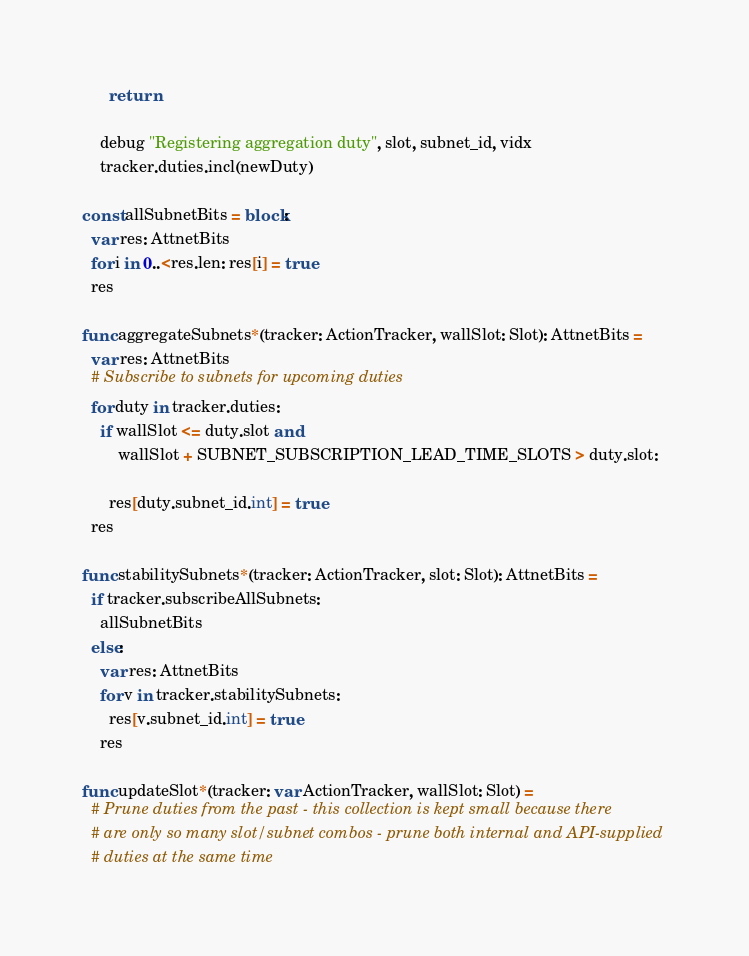<code> <loc_0><loc_0><loc_500><loc_500><_Nim_>      return

    debug "Registering aggregation duty", slot, subnet_id, vidx
    tracker.duties.incl(newDuty)

const allSubnetBits = block:
  var res: AttnetBits
  for i in 0..<res.len: res[i] = true
  res

func aggregateSubnets*(tracker: ActionTracker, wallSlot: Slot): AttnetBits =
  var res: AttnetBits
  # Subscribe to subnets for upcoming duties
  for duty in tracker.duties:
    if wallSlot <= duty.slot and
        wallSlot + SUBNET_SUBSCRIPTION_LEAD_TIME_SLOTS > duty.slot:

      res[duty.subnet_id.int] = true
  res

func stabilitySubnets*(tracker: ActionTracker, slot: Slot): AttnetBits =
  if tracker.subscribeAllSubnets:
    allSubnetBits
  else:
    var res: AttnetBits
    for v in tracker.stabilitySubnets:
      res[v.subnet_id.int] = true
    res

func updateSlot*(tracker: var ActionTracker, wallSlot: Slot) =
  # Prune duties from the past - this collection is kept small because there
  # are only so many slot/subnet combos - prune both internal and API-supplied
  # duties at the same time</code> 